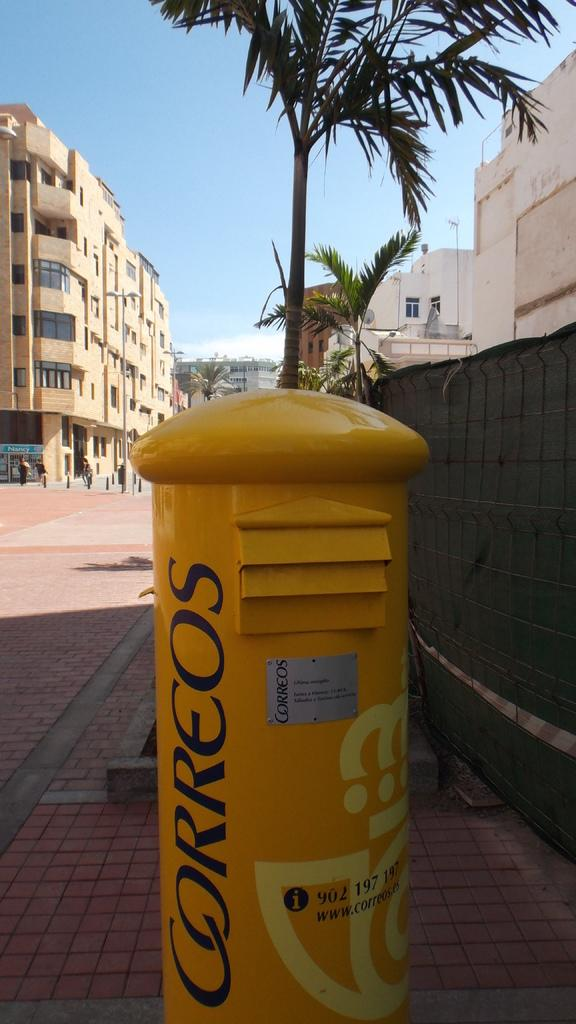<image>
Provide a brief description of the given image. A yellow post has the word Correos written on it. 